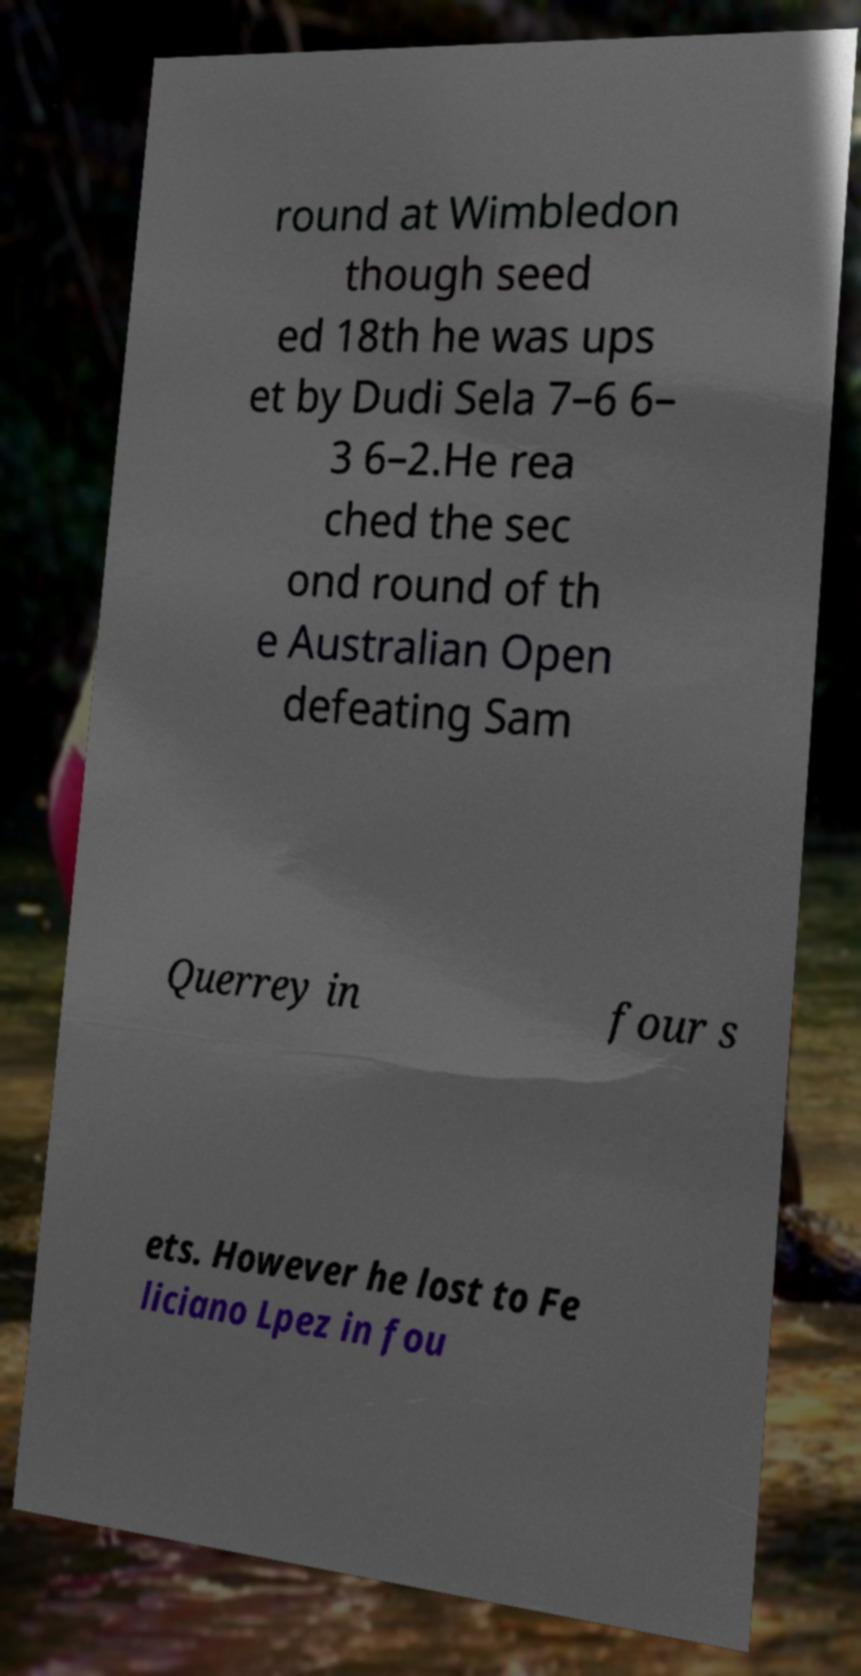For documentation purposes, I need the text within this image transcribed. Could you provide that? round at Wimbledon though seed ed 18th he was ups et by Dudi Sela 7–6 6– 3 6–2.He rea ched the sec ond round of th e Australian Open defeating Sam Querrey in four s ets. However he lost to Fe liciano Lpez in fou 